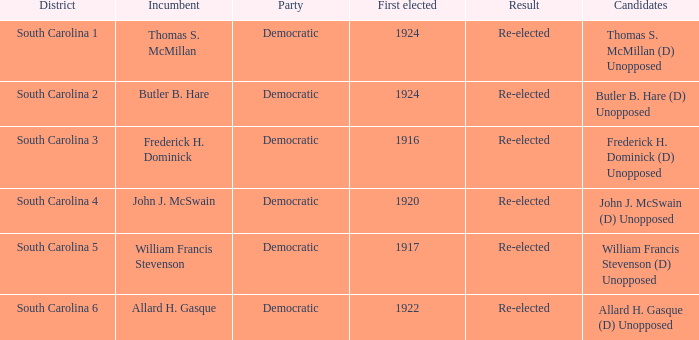Would you be able to parse every entry in this table? {'header': ['District', 'Incumbent', 'Party', 'First elected', 'Result', 'Candidates'], 'rows': [['South Carolina 1', 'Thomas S. McMillan', 'Democratic', '1924', 'Re-elected', 'Thomas S. McMillan (D) Unopposed'], ['South Carolina 2', 'Butler B. Hare', 'Democratic', '1924', 'Re-elected', 'Butler B. Hare (D) Unopposed'], ['South Carolina 3', 'Frederick H. Dominick', 'Democratic', '1916', 'Re-elected', 'Frederick H. Dominick (D) Unopposed'], ['South Carolina 4', 'John J. McSwain', 'Democratic', '1920', 'Re-elected', 'John J. McSwain (D) Unopposed'], ['South Carolina 5', 'William Francis Stevenson', 'Democratic', '1917', 'Re-elected', 'William Francis Stevenson (D) Unopposed'], ['South Carolina 6', 'Allard H. Gasque', 'Democratic', '1922', 'Re-elected', 'Allard H. Gasque (D) Unopposed']]} In the south carolina 5 district, what is the total sum of results? 1.0. 